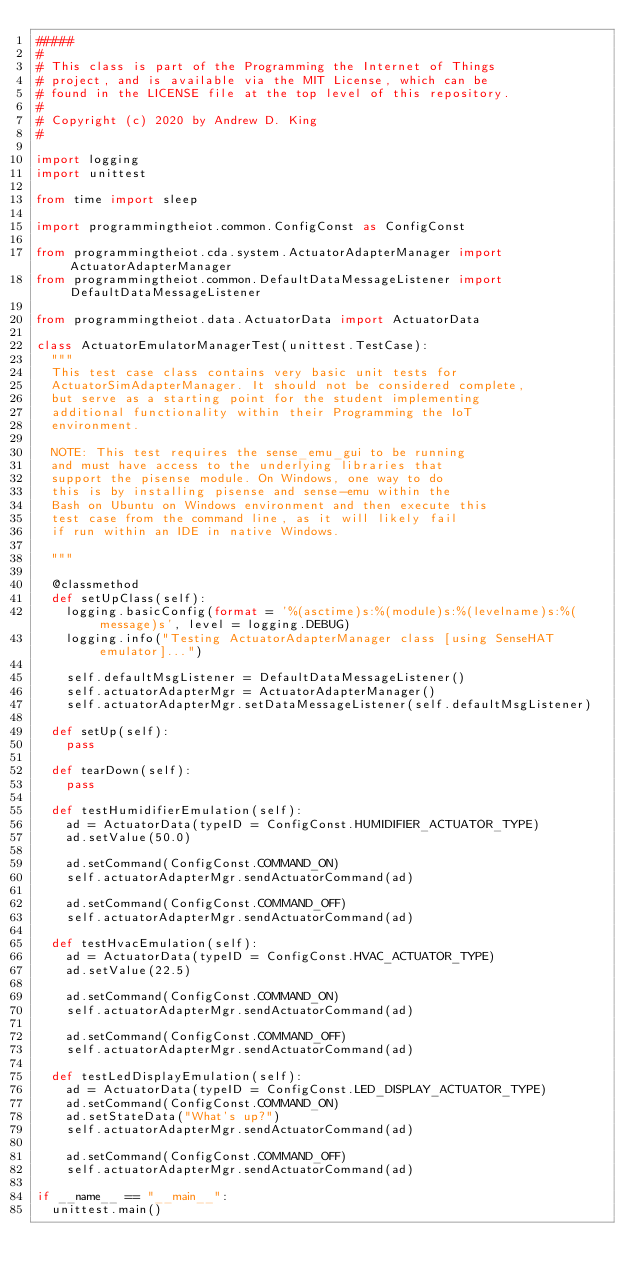<code> <loc_0><loc_0><loc_500><loc_500><_Python_>#####
# 
# This class is part of the Programming the Internet of Things
# project, and is available via the MIT License, which can be
# found in the LICENSE file at the top level of this repository.
# 
# Copyright (c) 2020 by Andrew D. King
# 

import logging
import unittest

from time import sleep

import programmingtheiot.common.ConfigConst as ConfigConst

from programmingtheiot.cda.system.ActuatorAdapterManager import ActuatorAdapterManager
from programmingtheiot.common.DefaultDataMessageListener import DefaultDataMessageListener

from programmingtheiot.data.ActuatorData import ActuatorData

class ActuatorEmulatorManagerTest(unittest.TestCase):
	"""
	This test case class contains very basic unit tests for
	ActuatorSimAdapterManager. It should not be considered complete,
	but serve as a starting point for the student implementing
	additional functionality within their Programming the IoT
	environment.
	
	NOTE: This test requires the sense_emu_gui to be running
	and must have access to the underlying libraries that
	support the pisense module. On Windows, one way to do
	this is by installing pisense and sense-emu within the
	Bash on Ubuntu on Windows environment and then execute this
	test case from the command line, as it will likely fail
	if run within an IDE in native Windows.
	
	"""
	
	@classmethod
	def setUpClass(self):
		logging.basicConfig(format = '%(asctime)s:%(module)s:%(levelname)s:%(message)s', level = logging.DEBUG)
		logging.info("Testing ActuatorAdapterManager class [using SenseHAT emulator]...")
		
		self.defaultMsgListener = DefaultDataMessageListener()
		self.actuatorAdapterMgr = ActuatorAdapterManager()
		self.actuatorAdapterMgr.setDataMessageListener(self.defaultMsgListener)
		
	def setUp(self):
		pass

	def tearDown(self):
		pass

	def testHumidifierEmulation(self):
		ad = ActuatorData(typeID = ConfigConst.HUMIDIFIER_ACTUATOR_TYPE)
		ad.setValue(50.0)
		
		ad.setCommand(ConfigConst.COMMAND_ON)
		self.actuatorAdapterMgr.sendActuatorCommand(ad)
		
		ad.setCommand(ConfigConst.COMMAND_OFF)
		self.actuatorAdapterMgr.sendActuatorCommand(ad)

	def testHvacEmulation(self):
		ad = ActuatorData(typeID = ConfigConst.HVAC_ACTUATOR_TYPE)
		ad.setValue(22.5)
		
		ad.setCommand(ConfigConst.COMMAND_ON)
		self.actuatorAdapterMgr.sendActuatorCommand(ad)
		
		ad.setCommand(ConfigConst.COMMAND_OFF)
		self.actuatorAdapterMgr.sendActuatorCommand(ad)

	def testLedDisplayEmulation(self):
		ad = ActuatorData(typeID = ConfigConst.LED_DISPLAY_ACTUATOR_TYPE)
		ad.setCommand(ConfigConst.COMMAND_ON)
		ad.setStateData("What's up?")
		self.actuatorAdapterMgr.sendActuatorCommand(ad)
		
		ad.setCommand(ConfigConst.COMMAND_OFF)
		self.actuatorAdapterMgr.sendActuatorCommand(ad)

if __name__ == "__main__":
	unittest.main()
	</code> 